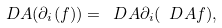<formula> <loc_0><loc_0><loc_500><loc_500>\ D A ( \partial _ { i } ( f ) ) = \ D A \partial _ { i } ( \ D A f ) ,</formula> 